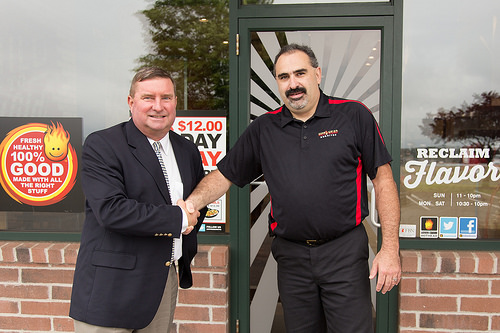<image>
Is there a man behind the door? No. The man is not behind the door. From this viewpoint, the man appears to be positioned elsewhere in the scene. 